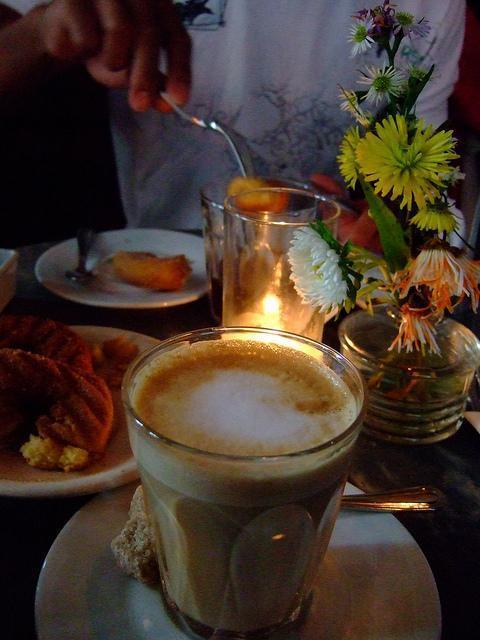How many cups are there?
Give a very brief answer. 2. How many vases are there?
Give a very brief answer. 1. 